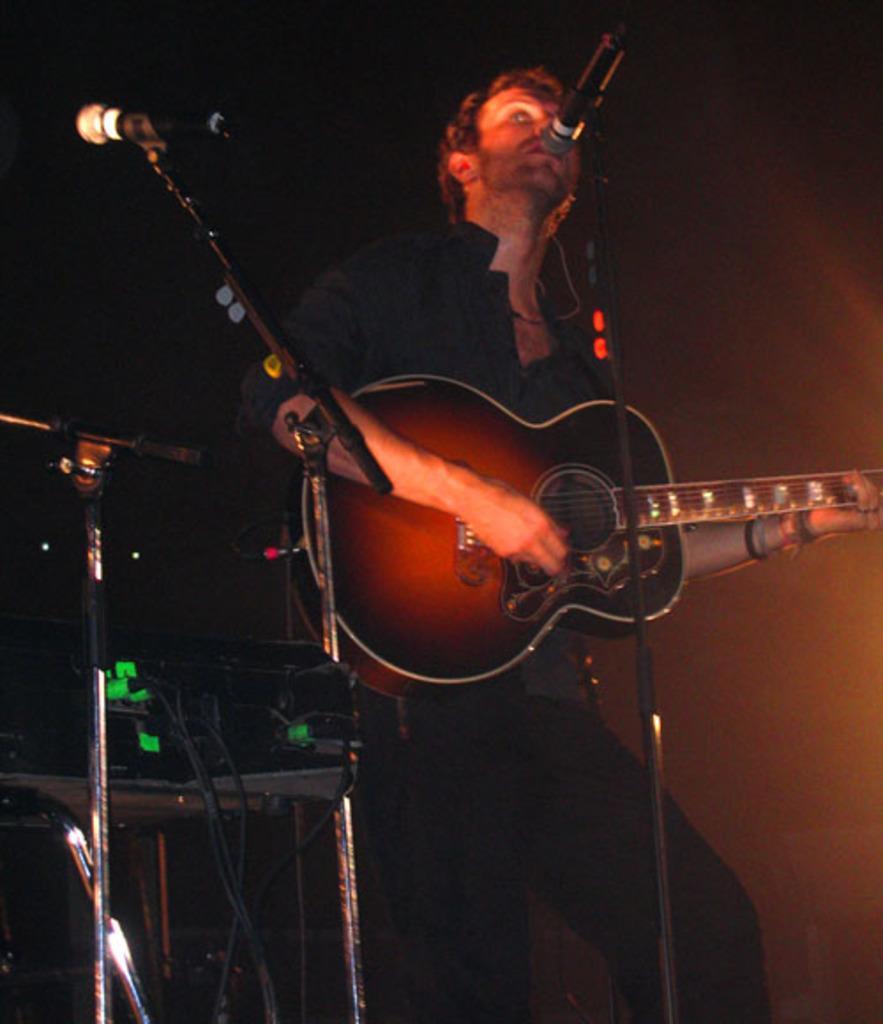How would you summarize this image in a sentence or two? In this image i can see a person standing and holding a guitar in his hands. I can see a microphone in front of him. 